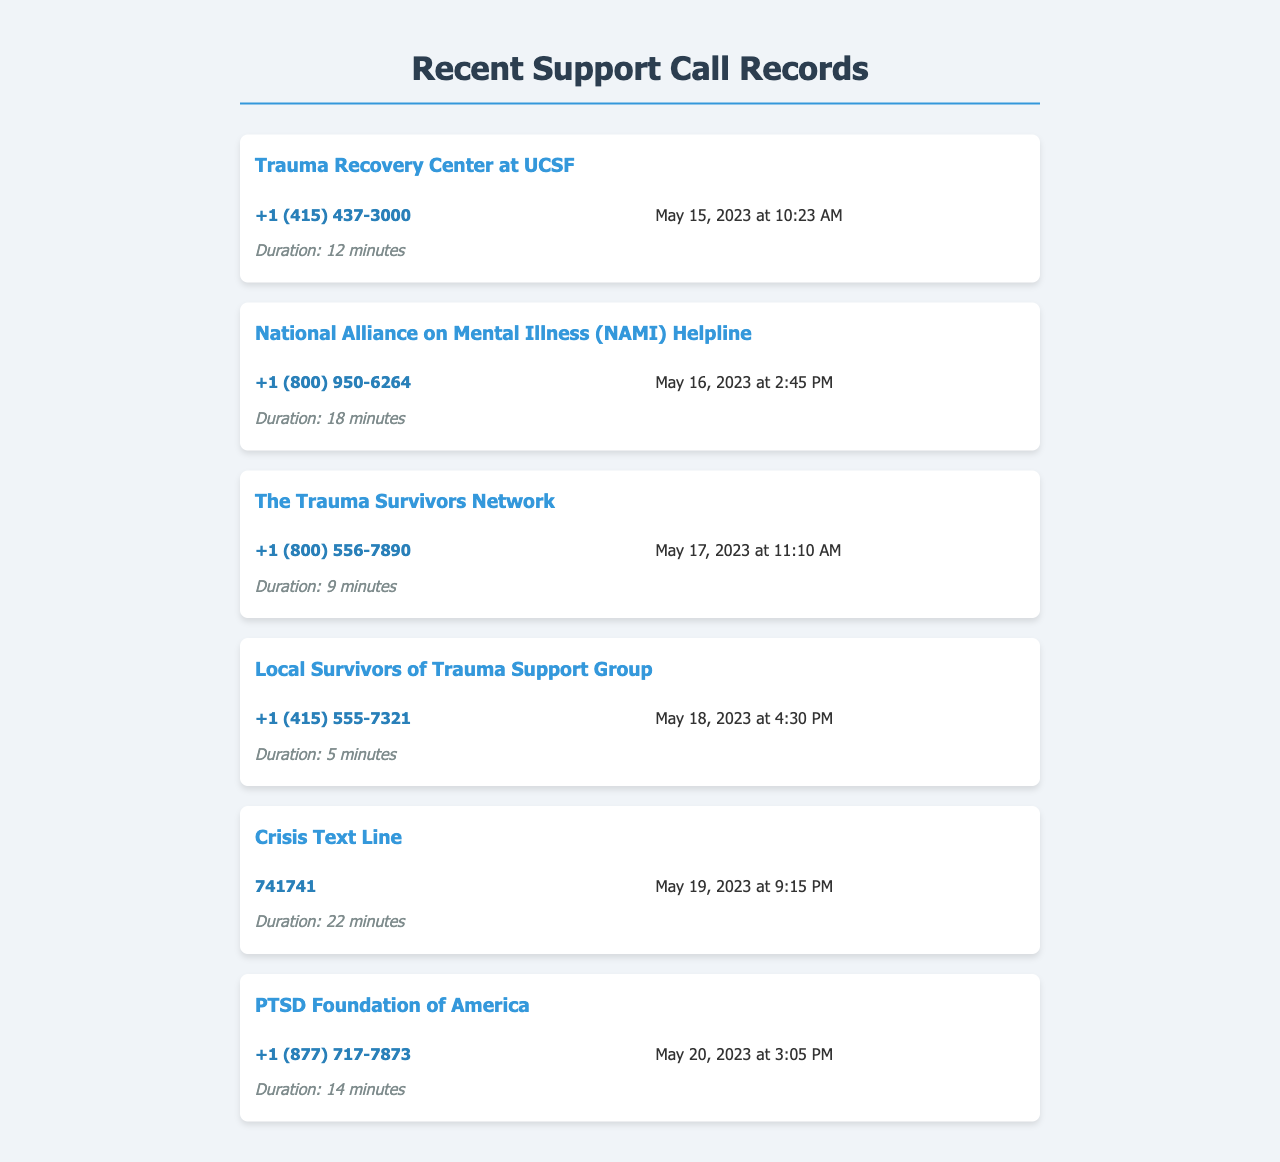What is the phone number of the Trauma Recovery Center at UCSF? The document includes the phone number associated with the Trauma Recovery Center at UCSF, which is located in the call record section.
Answer: +1 (415) 437-3000 How long was the call to the National Alliance on Mental Illness (NAMI) Helpline? The duration of the call to the NAMI Helpline is specified in the call record, indicating the length of time spent on the call.
Answer: 18 minutes What date was the call made to The Trauma Survivors Network? The document provides the specific date for each call, including the call to The Trauma Survivors Network.
Answer: May 17, 2023 Which local support group was contacted at 4:30 PM? The time of 4:30 PM is associated with a specific support group mentioned in the call records.
Answer: Local Survivors of Trauma Support Group What is the total number of calls recorded? The document lists all the calls made, and counting them gives the total number of calls recorded in the support records.
Answer: 6 Which organization offers a crisis text line? The document mentions a specific organization that provides a crisis text line among the recorded calls.
Answer: Crisis Text Line 